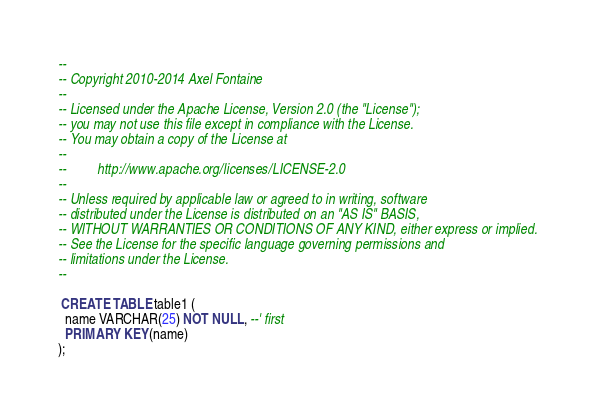Convert code to text. <code><loc_0><loc_0><loc_500><loc_500><_SQL_>--
-- Copyright 2010-2014 Axel Fontaine
--
-- Licensed under the Apache License, Version 2.0 (the "License");
-- you may not use this file except in compliance with the License.
-- You may obtain a copy of the License at
--
--         http://www.apache.org/licenses/LICENSE-2.0
--
-- Unless required by applicable law or agreed to in writing, software
-- distributed under the License is distributed on an "AS IS" BASIS,
-- WITHOUT WARRANTIES OR CONDITIONS OF ANY KIND, either express or implied.
-- See the License for the specific language governing permissions and
-- limitations under the License.
--

 CREATE TABLE table1 (
  name VARCHAR(25) NOT NULL, --' first
  PRIMARY KEY(name)
);
</code> 